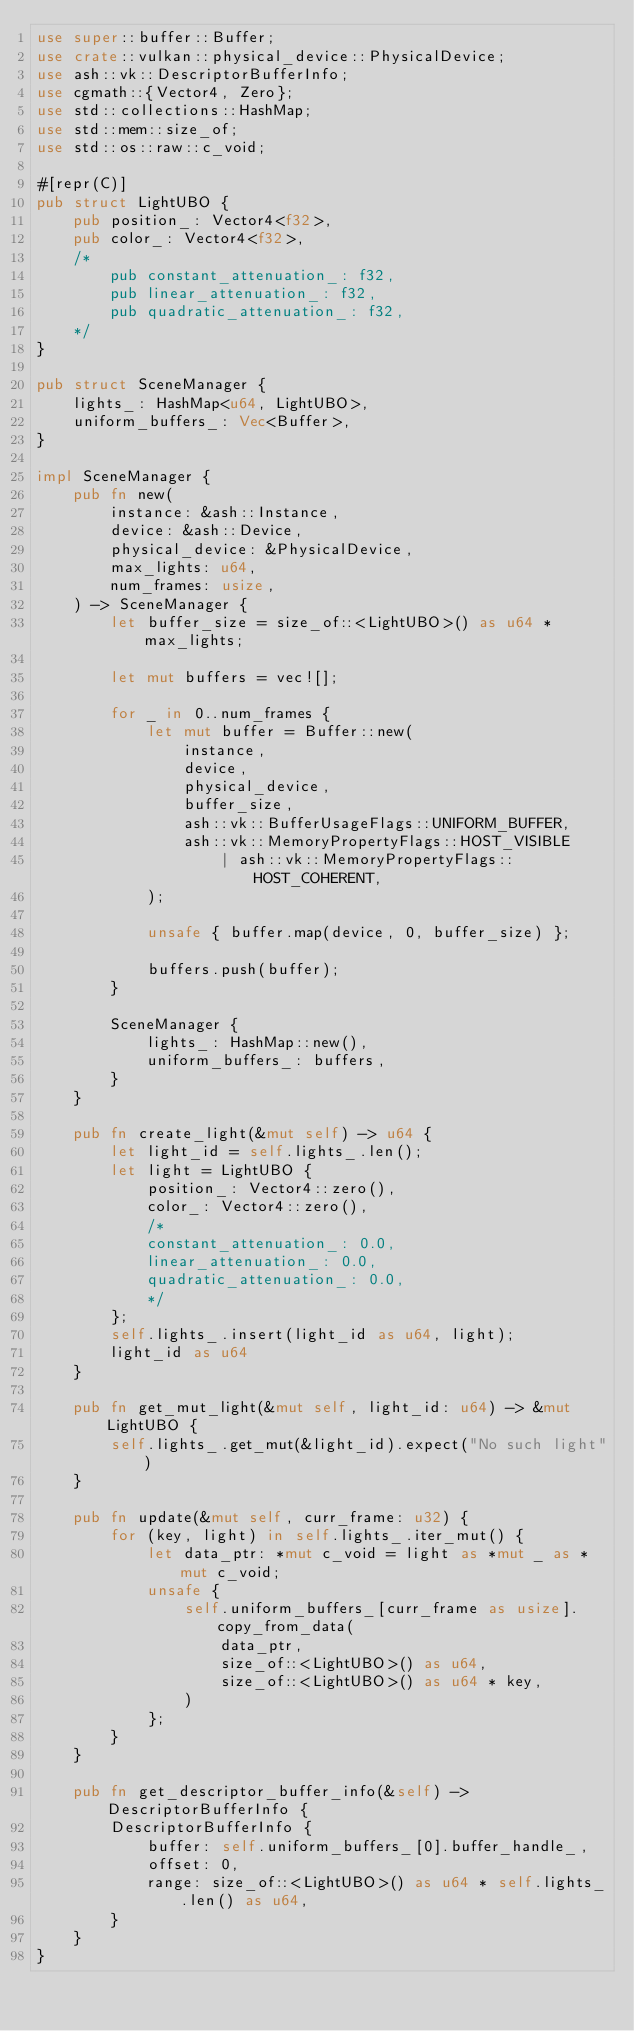Convert code to text. <code><loc_0><loc_0><loc_500><loc_500><_Rust_>use super::buffer::Buffer;
use crate::vulkan::physical_device::PhysicalDevice;
use ash::vk::DescriptorBufferInfo;
use cgmath::{Vector4, Zero};
use std::collections::HashMap;
use std::mem::size_of;
use std::os::raw::c_void;

#[repr(C)]
pub struct LightUBO {
    pub position_: Vector4<f32>,
    pub color_: Vector4<f32>,
    /*
        pub constant_attenuation_: f32,
        pub linear_attenuation_: f32,
        pub quadratic_attenuation_: f32,
    */
}

pub struct SceneManager {
    lights_: HashMap<u64, LightUBO>,
    uniform_buffers_: Vec<Buffer>,
}

impl SceneManager {
    pub fn new(
        instance: &ash::Instance,
        device: &ash::Device,
        physical_device: &PhysicalDevice,
        max_lights: u64,
        num_frames: usize,
    ) -> SceneManager {
        let buffer_size = size_of::<LightUBO>() as u64 * max_lights;

        let mut buffers = vec![];

        for _ in 0..num_frames {
            let mut buffer = Buffer::new(
                instance,
                device,
                physical_device,
                buffer_size,
                ash::vk::BufferUsageFlags::UNIFORM_BUFFER,
                ash::vk::MemoryPropertyFlags::HOST_VISIBLE
                    | ash::vk::MemoryPropertyFlags::HOST_COHERENT,
            );

            unsafe { buffer.map(device, 0, buffer_size) };

            buffers.push(buffer);
        }

        SceneManager {
            lights_: HashMap::new(),
            uniform_buffers_: buffers,
        }
    }

    pub fn create_light(&mut self) -> u64 {
        let light_id = self.lights_.len();
        let light = LightUBO {
            position_: Vector4::zero(),
            color_: Vector4::zero(),
            /*
            constant_attenuation_: 0.0,
            linear_attenuation_: 0.0,
            quadratic_attenuation_: 0.0,
            */
        };
        self.lights_.insert(light_id as u64, light);
        light_id as u64
    }

    pub fn get_mut_light(&mut self, light_id: u64) -> &mut LightUBO {
        self.lights_.get_mut(&light_id).expect("No such light")
    }

    pub fn update(&mut self, curr_frame: u32) {
        for (key, light) in self.lights_.iter_mut() {
            let data_ptr: *mut c_void = light as *mut _ as *mut c_void;
            unsafe {
                self.uniform_buffers_[curr_frame as usize].copy_from_data(
                    data_ptr,
                    size_of::<LightUBO>() as u64,
                    size_of::<LightUBO>() as u64 * key,
                )
            };
        }
    }

    pub fn get_descriptor_buffer_info(&self) -> DescriptorBufferInfo {
        DescriptorBufferInfo {
            buffer: self.uniform_buffers_[0].buffer_handle_,
            offset: 0,
            range: size_of::<LightUBO>() as u64 * self.lights_.len() as u64,
        }
    }
}
</code> 